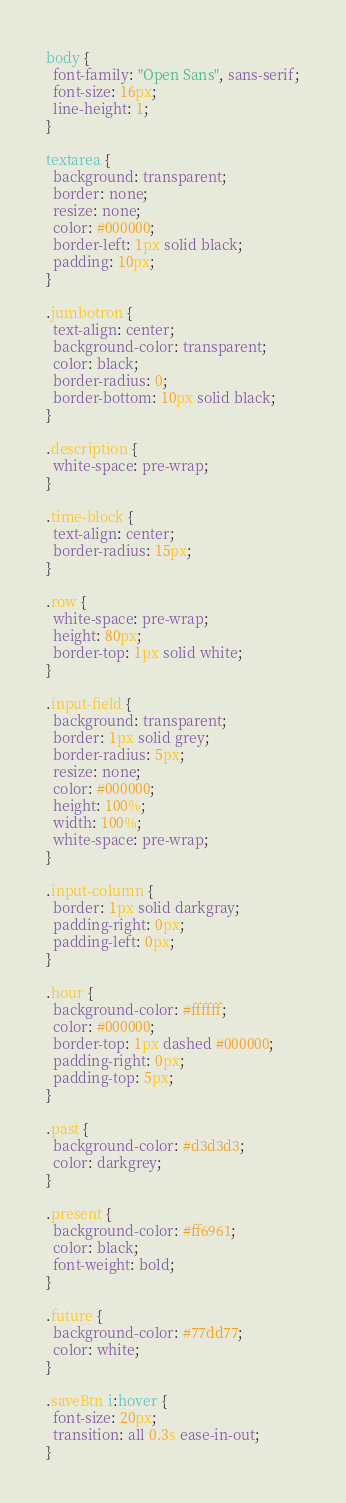<code> <loc_0><loc_0><loc_500><loc_500><_CSS_>body {
  font-family: "Open Sans", sans-serif;
  font-size: 16px;
  line-height: 1;
}

textarea {
  background: transparent;
  border: none;
  resize: none;
  color: #000000;
  border-left: 1px solid black;
  padding: 10px;
}

.jumbotron {
  text-align: center;
  background-color: transparent;
  color: black;
  border-radius: 0;
  border-bottom: 10px solid black;
}

.description {
  white-space: pre-wrap;
}

.time-block {
  text-align: center;
  border-radius: 15px;
}

.row {
  white-space: pre-wrap;
  height: 80px;
  border-top: 1px solid white;
}

.input-field {
  background: transparent;
  border: 1px solid grey;
  border-radius: 5px;
  resize: none;
  color: #000000;
  height: 100%;
  width: 100%;
  white-space: pre-wrap;
}

.input-column {
  border: 1px solid darkgray;
  padding-right: 0px;
  padding-left: 0px;
}

.hour {
  background-color: #ffffff;
  color: #000000;
  border-top: 1px dashed #000000;
  padding-right: 0px;
  padding-top: 5px;
}

.past {
  background-color: #d3d3d3;
  color: darkgrey;
}

.present {
  background-color: #ff6961;
  color: black;
  font-weight: bold;
}

.future {
  background-color: #77dd77;
  color: white;
}

.saveBtn i:hover {
  font-size: 20px;
  transition: all 0.3s ease-in-out;
}
</code> 